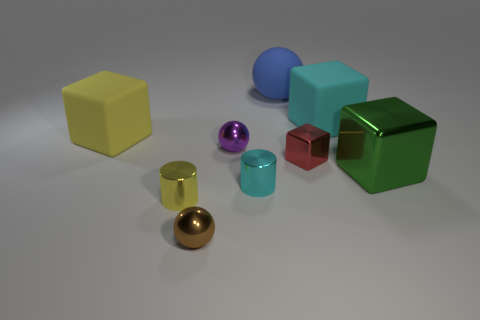How many objects are there in total in the image? The image displays a total of eight objects, each varying in shape and color. Could you describe the shapes of the objects? Certainly! There are cubes, spheres, a cylinder, and what appears to be a hollow square or a frame. Each has distinct geometry, contributing to the variety in the scene. 